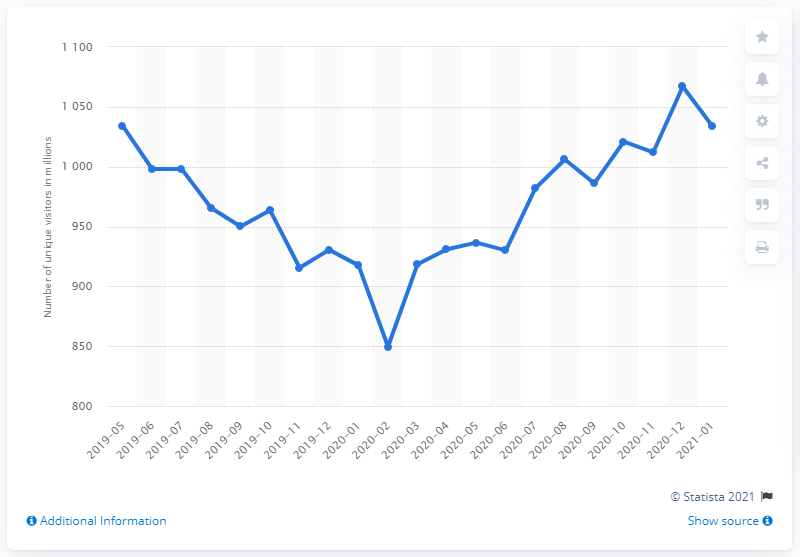Outline some significant characteristics in this image. In January 2020, Bing.com was visited by 963.5 unique global visitors. In January 2021, Bing.com had 1034 unique global visitors. 